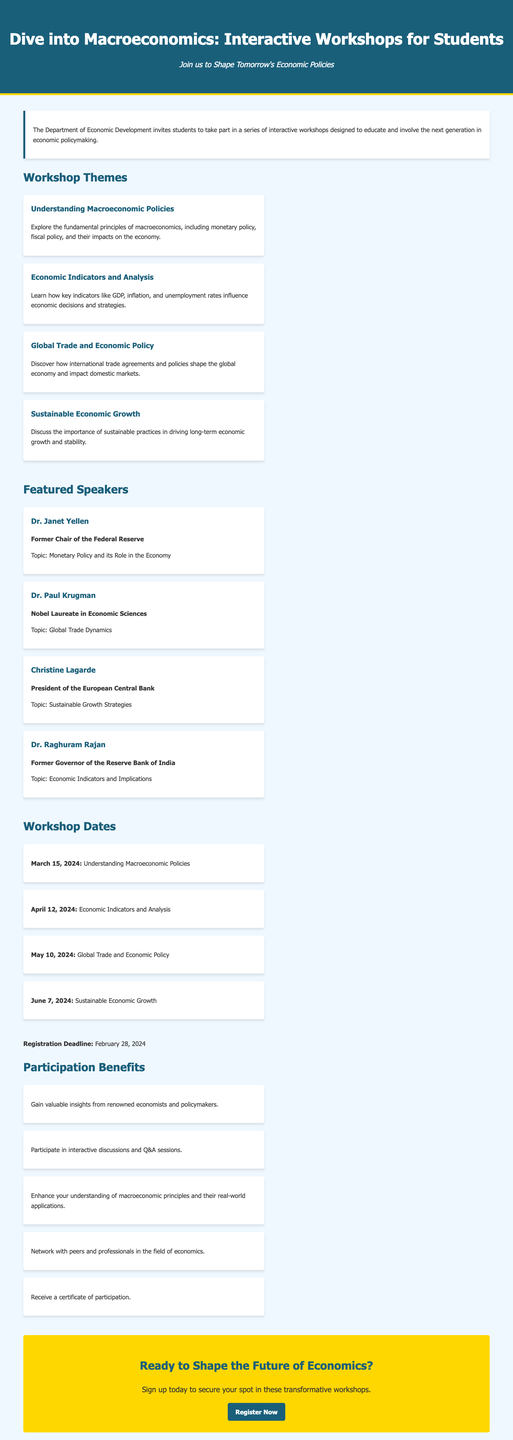What are the workshop themes? The workshop themes include various topics in macroeconomics, each addressing specific principles and practices.
Answer: Understanding Macroeconomic Policies, Economic Indicators and Analysis, Global Trade and Economic Policy, Sustainable Economic Growth Who is the featured speaker on Sustainable Growth Strategies? The featured speaker for this topic is someone notable, which is essential to understand the perspective offered.
Answer: Christine Lagarde What is the registration deadline for the workshops? The registration deadline is clearly stated in the document and is a crucial date for interested participants.
Answer: February 28, 2024 When is the workshop on Economic Indicators and Analysis? The specific date for this workshop is important for attendees to know when to participate in this educational opportunity.
Answer: April 12, 2024 What benefit is offered to participants in these workshops? The advertisement highlights specific benefits that students can gain by attending the workshops.
Answer: Gain valuable insights from renowned economists and policymakers How many workshops are scheduled? The number of workshops indicates the breadth of coverage in the program. Counting the listed workshops yields the answer.
Answer: Four 